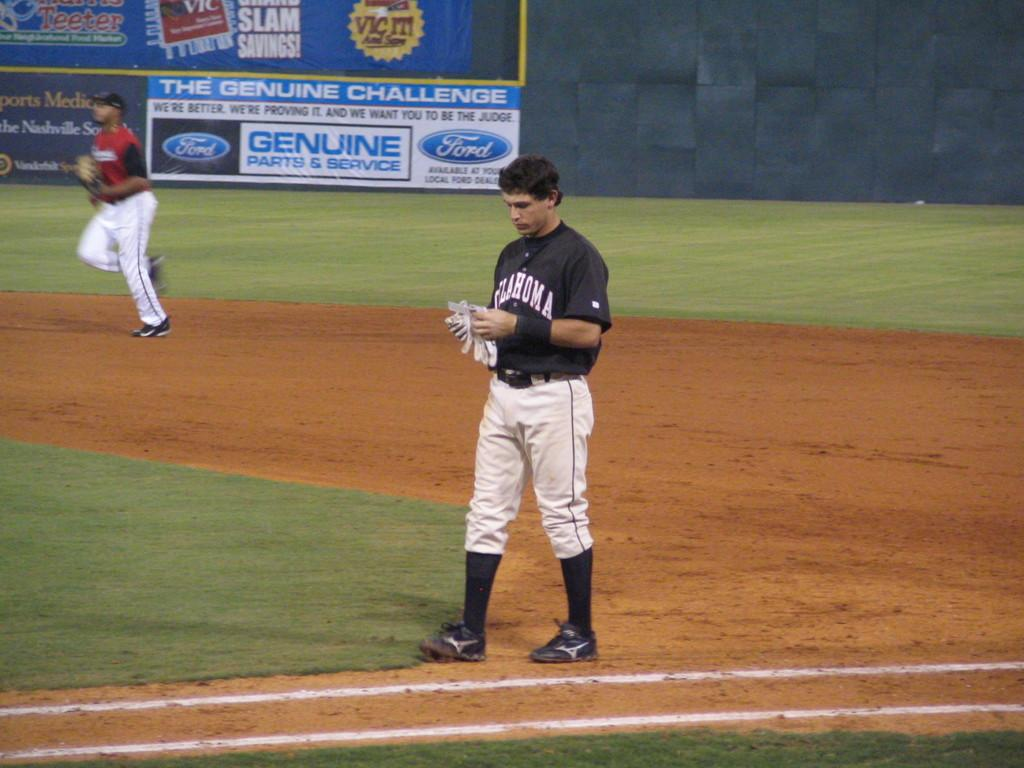<image>
Create a compact narrative representing the image presented. a baseball player wearing a baseball uniform that says 'oklahoma' on it 